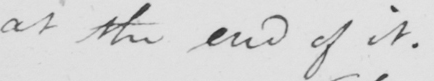What does this handwritten line say? at the end of it . 